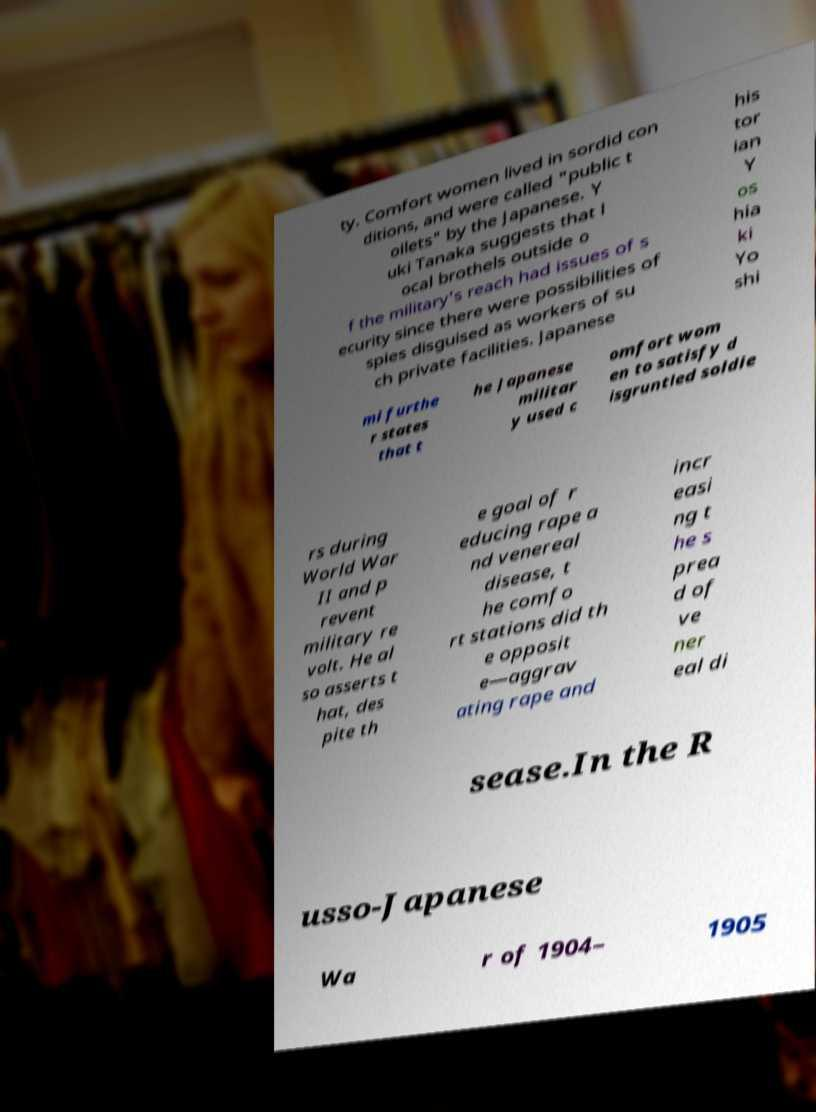Please identify and transcribe the text found in this image. ty. Comfort women lived in sordid con ditions, and were called "public t oilets" by the Japanese. Y uki Tanaka suggests that l ocal brothels outside o f the military's reach had issues of s ecurity since there were possibilities of spies disguised as workers of su ch private facilities. Japanese his tor ian Y os hia ki Yo shi mi furthe r states that t he Japanese militar y used c omfort wom en to satisfy d isgruntled soldie rs during World War II and p revent military re volt. He al so asserts t hat, des pite th e goal of r educing rape a nd venereal disease, t he comfo rt stations did th e opposit e—aggrav ating rape and incr easi ng t he s prea d of ve ner eal di sease.In the R usso-Japanese Wa r of 1904– 1905 